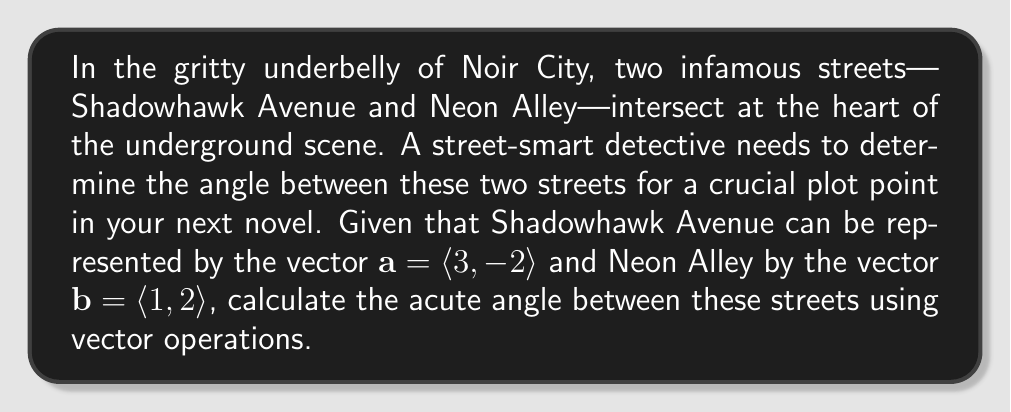What is the answer to this math problem? To find the angle between two vectors, we can use the dot product formula:

$$\cos \theta = \frac{\mathbf{a} \cdot \mathbf{b}}{|\mathbf{a}| |\mathbf{b}|}$$

Where $\theta$ is the angle between the vectors, $\mathbf{a} \cdot \mathbf{b}$ is the dot product, and $|\mathbf{a}|$ and $|\mathbf{b}|$ are the magnitudes of vectors $\mathbf{a}$ and $\mathbf{b}$ respectively.

Step 1: Calculate the dot product $\mathbf{a} \cdot \mathbf{b}$
$$\mathbf{a} \cdot \mathbf{b} = (3)(1) + (-2)(2) = 3 - 4 = -1$$

Step 2: Calculate the magnitudes of $\mathbf{a}$ and $\mathbf{b}$
$$|\mathbf{a}| = \sqrt{3^2 + (-2)^2} = \sqrt{9 + 4} = \sqrt{13}$$
$$|\mathbf{b}| = \sqrt{1^2 + 2^2} = \sqrt{1 + 4} = \sqrt{5}$$

Step 3: Substitute into the cosine formula
$$\cos \theta = \frac{-1}{\sqrt{13} \cdot \sqrt{5}}$$

Step 4: Take the inverse cosine (arccos) of both sides
$$\theta = \arccos\left(\frac{-1}{\sqrt{65}}\right)$$

Step 5: Calculate the result (in degrees)
$$\theta \approx 97.18°$$

Since we're asked for the acute angle, we subtract this from 180°:

$$180° - 97.18° = 82.82°$$
Answer: The acute angle between Shadowhawk Avenue and Neon Alley is approximately 82.82°. 